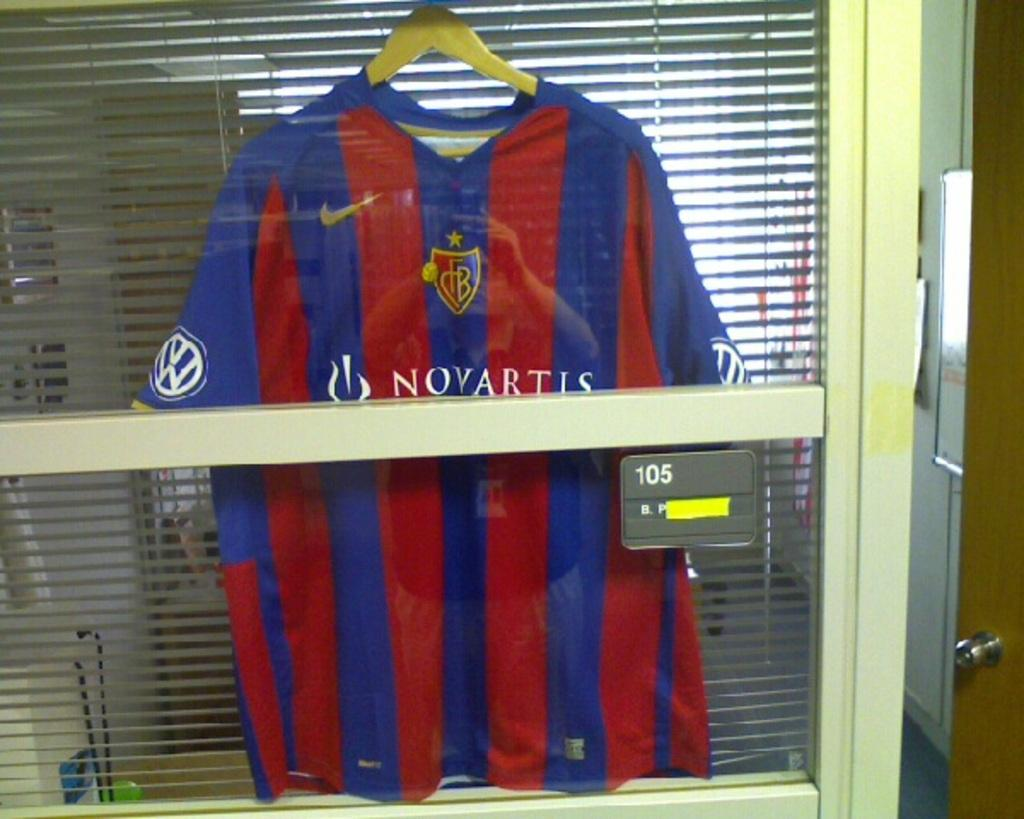<image>
Render a clear and concise summary of the photo. A Novartis jersey is hanging in the window. 